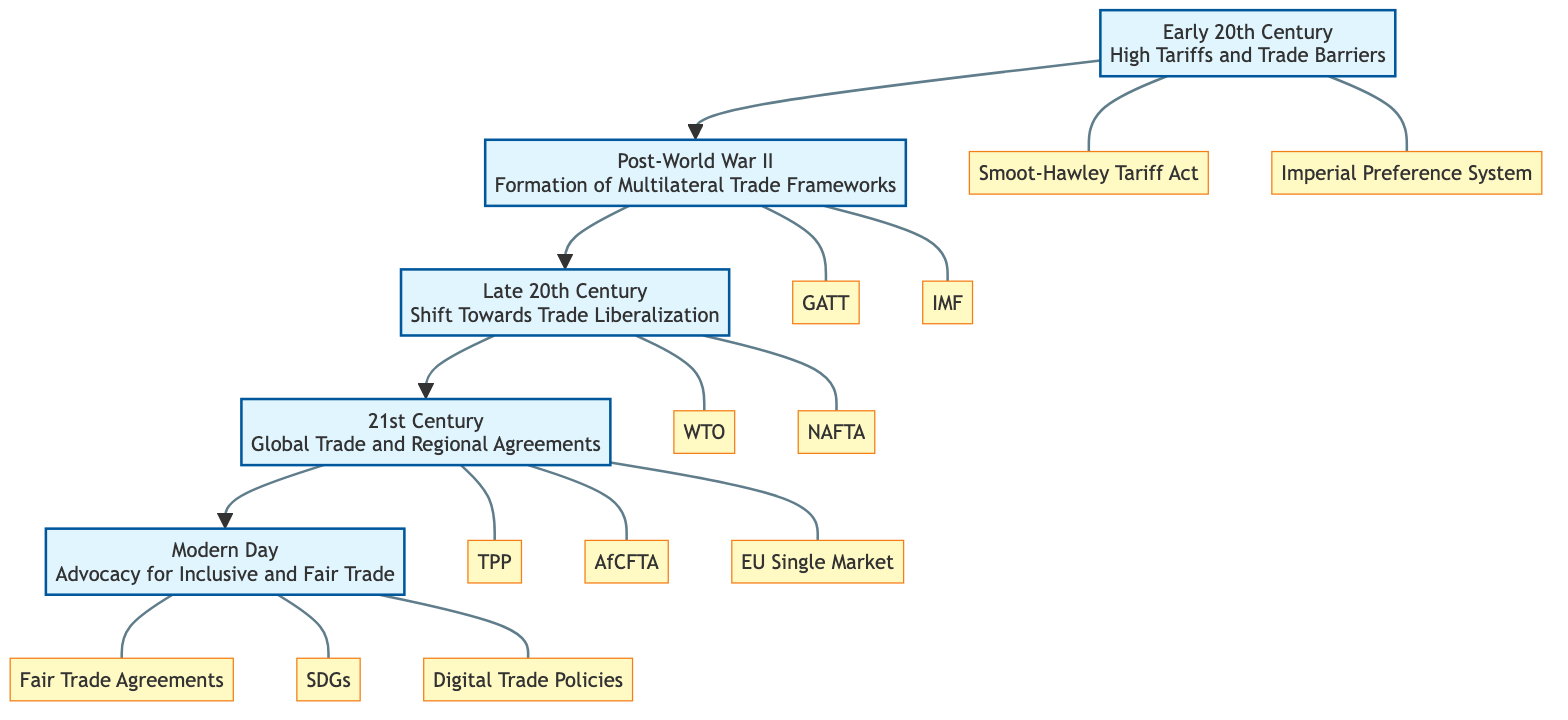What is the highest level in the diagram? The highest level in the diagram, which is the topmost node, is "Modern Day." It is the fifth level in the sequence of levels presented.
Answer: Modern Day Which entity is associated with the "Early 20th Century"? The "Early 20th Century" level includes two entities: the "Smoot-Hawley Tariff Act" and the "Imperial Preference System." Including both, I identify them to answer the question.
Answer: Smoot-Hawley Tariff Act, Imperial Preference System How many levels are shown in the diagram? The diagram has five levels, starting from "Early 20th Century" at the bottom and ending with "Modern Day" at the top.
Answer: 5 What was formed in the "Post-World War II" era? The "Post-World War II" level is characterized by the formation of multilateral trade frameworks, specifically mentioning "GATT" and "International Monetary Fund." Therefore, the answer revolves around this formation aspect.
Answer: Formation of Multilateral Trade Frameworks Which agreement is introduced in the "21st Century"? The "21st Century" level features global trade initiatives, specifically mentioning the "Trans-Pacific Partnership," which is a notable agreement introduced during that time period.
Answer: Trans-Pacific Partnership What is the lowest level's description? The lowest level is "Early 20th Century," described as having "High Tariffs and Trade Barriers." This answer focuses strictly on the description element of the lowest node.
Answer: High Tariffs and Trade Barriers Which two entities are linked to the "Late 20th Century"? The "Late 20th Century" level links two entities: the "World Trade Organization" and "North American Free Trade Agreement." These are specifically tied to this historical period in trade policy.
Answer: WTO, NAFTA What is the main focus of the "Modern Day" level? The "Modern Day" level focuses on "Advocacy for Inclusive and Fair Trade," which describes the current approach to trade policies and practices emphasizing fairness and inclusivity.
Answer: Advocacy for Inclusive and Fair Trade What is the progression from "Late 20th Century" to "21st Century"? The progression from "Late 20th Century" to "21st Century" indicates a shift from trade liberalization to global trade and regional agreements, showcasing a broader integration of trade policies over time.
Answer: Shift Towards Trade Liberalization to Global Trade and Regional Agreements 